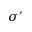Convert formula to latex. <formula><loc_0><loc_0><loc_500><loc_500>\sigma ^ { \prime }</formula> 